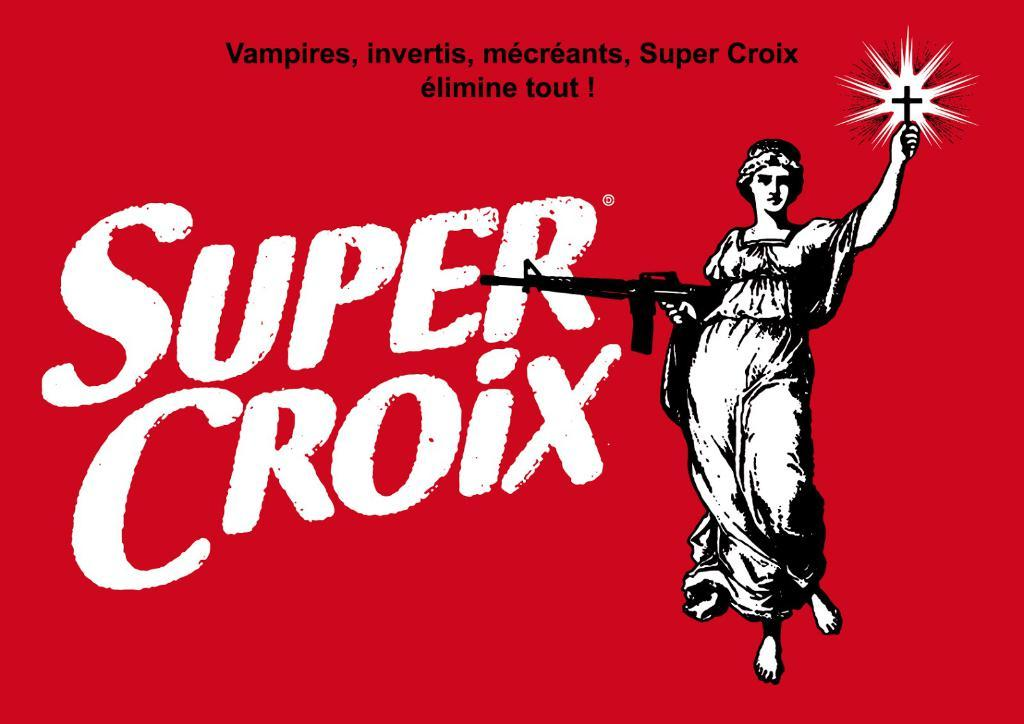Provide a one-sentence caption for the provided image. A red sign has Super Croix next to a woman holding a gun. 